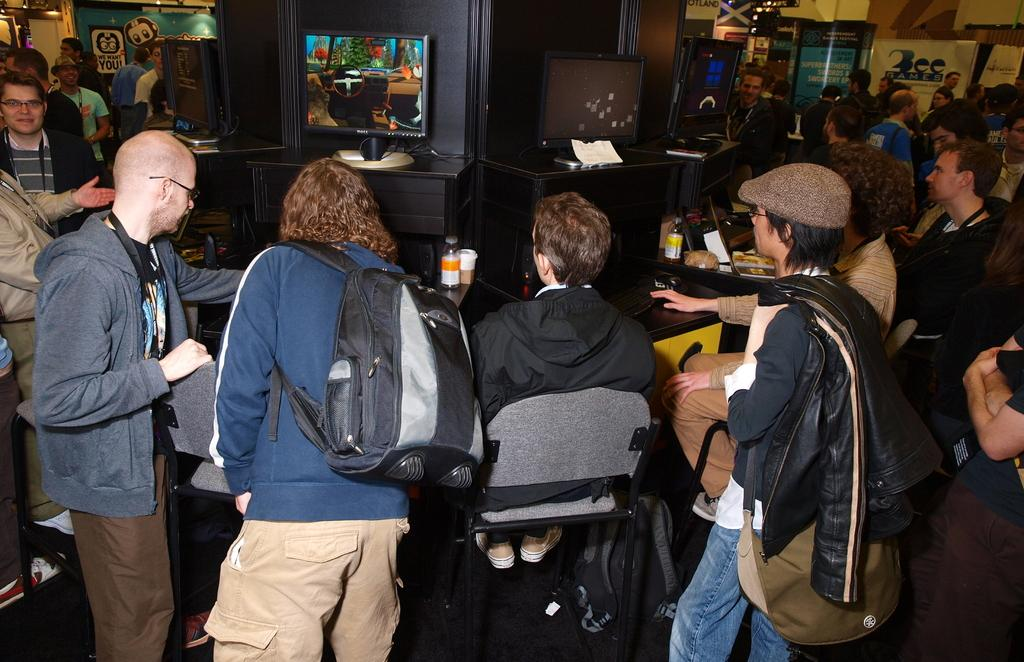What is happening in the image? There are people standing in the image. Where are the people standing? The people are standing on the floor. What can be seen in the background of the image? There are three televisions in the background of the image. How are the televisions positioned? The televisions are placed on desks. Can you hear the turkey cry in the image? There is no turkey present in the image, so it cannot be heard crying. 